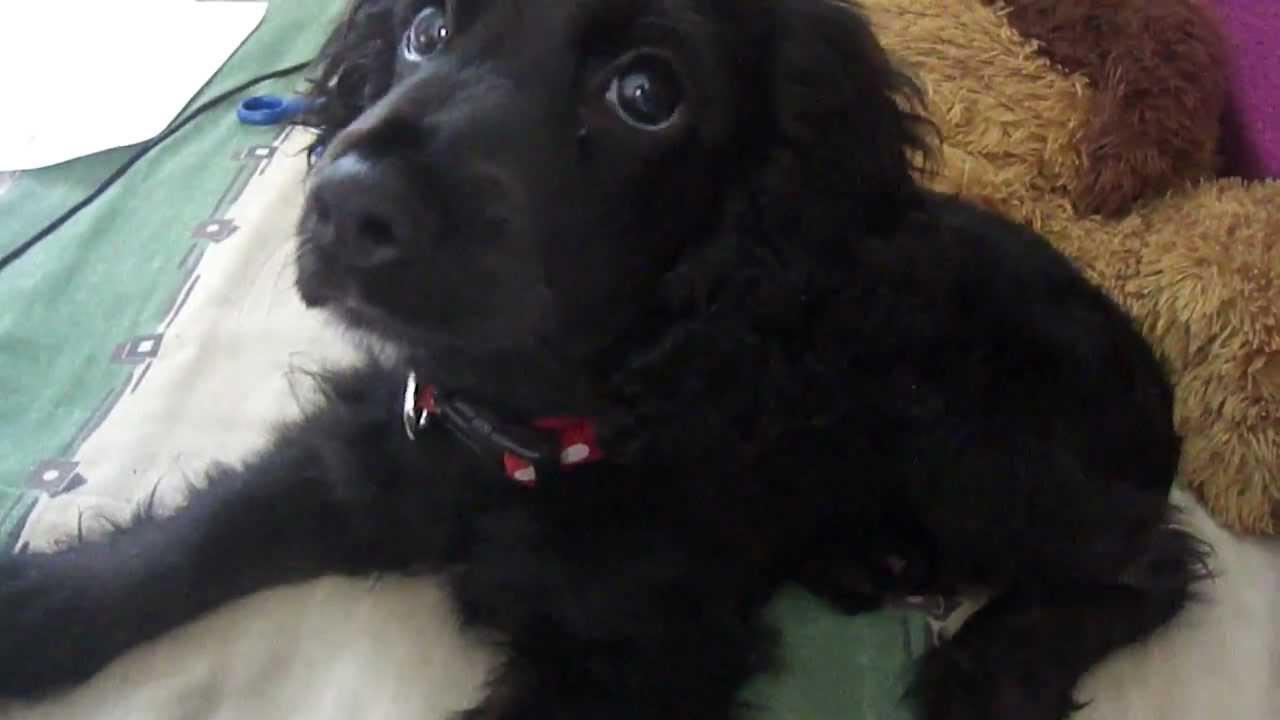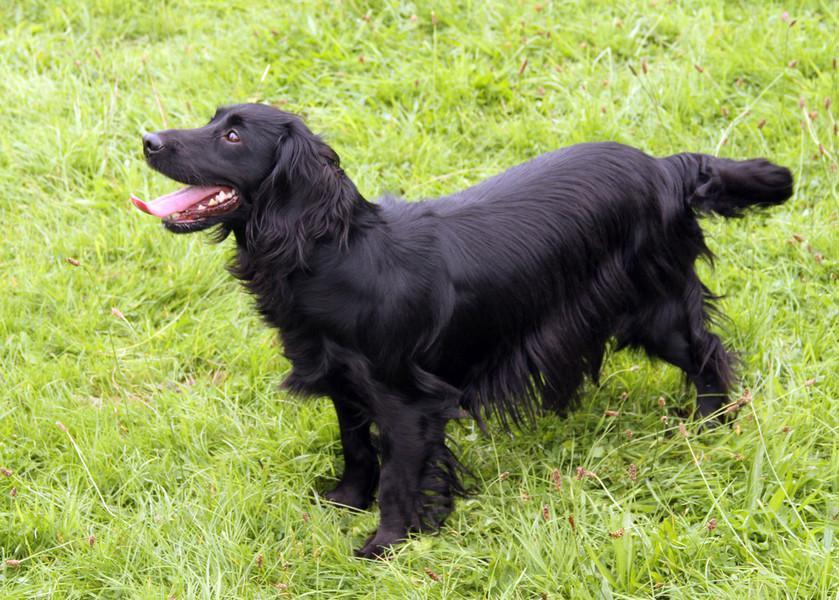The first image is the image on the left, the second image is the image on the right. Examine the images to the left and right. Is the description "The black dog in the image on the left is outside in the grass." accurate? Answer yes or no. No. The first image is the image on the left, the second image is the image on the right. Assess this claim about the two images: "An image shows a black-faced dog posed on green grass, touching some type of toy in front of it.". Correct or not? Answer yes or no. No. 